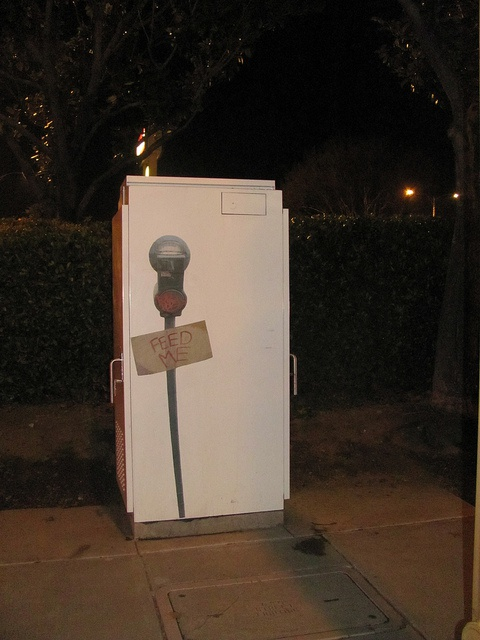Describe the objects in this image and their specific colors. I can see a parking meter in black, maroon, gray, and darkgray tones in this image. 